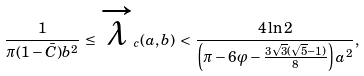<formula> <loc_0><loc_0><loc_500><loc_500>\frac { 1 } { \pi ( 1 - \bar { C } ) b ^ { 2 } } \, \leq \, \overrightarrow { \lambda } _ { c } ( a , b ) \, < \, \frac { 4 \ln 2 } { \left ( \pi - 6 \varphi - \frac { 3 \sqrt { 3 } ( \sqrt { 5 } - 1 ) } { 8 } \right ) a ^ { 2 } } ,</formula> 